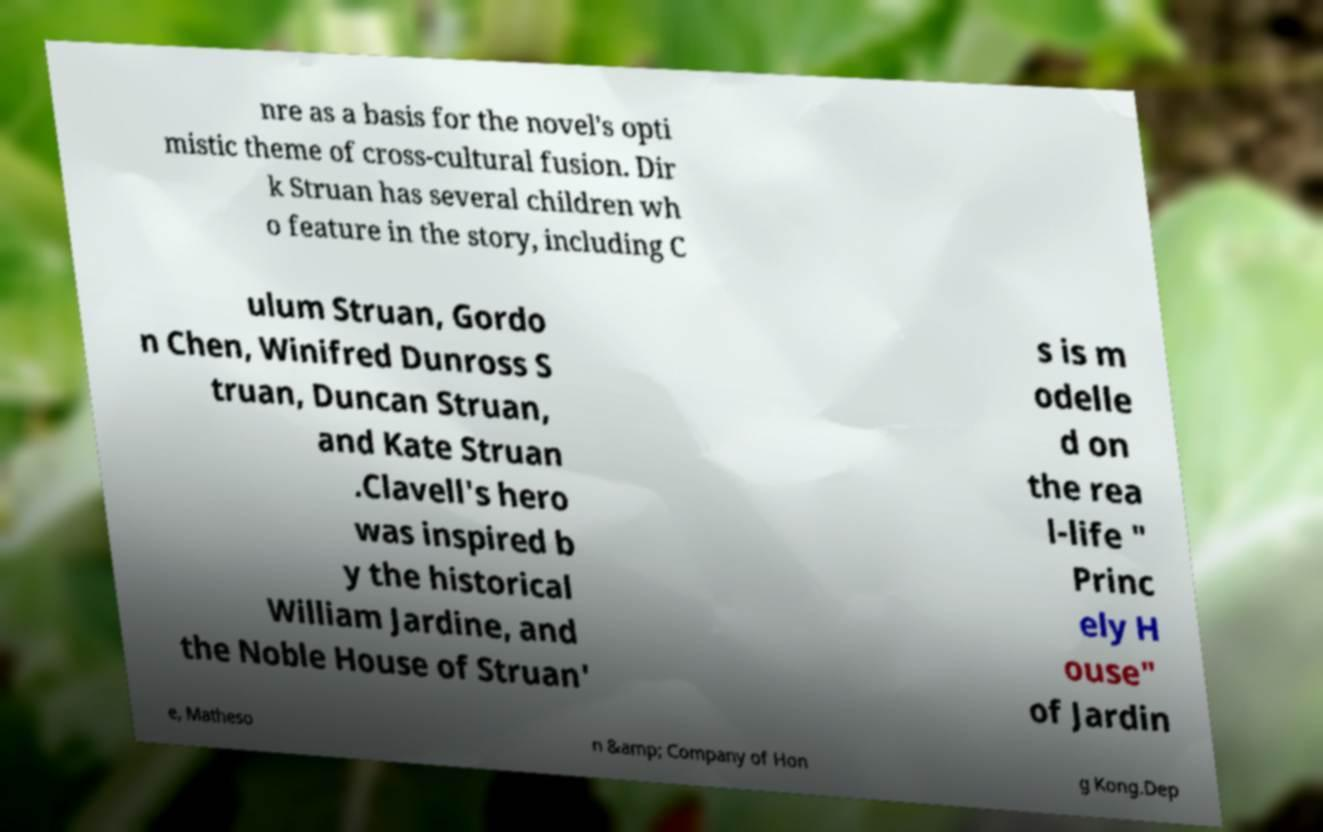What messages or text are displayed in this image? I need them in a readable, typed format. nre as a basis for the novel's opti mistic theme of cross-cultural fusion. Dir k Struan has several children wh o feature in the story, including C ulum Struan, Gordo n Chen, Winifred Dunross S truan, Duncan Struan, and Kate Struan .Clavell's hero was inspired b y the historical William Jardine, and the Noble House of Struan' s is m odelle d on the rea l-life " Princ ely H ouse" of Jardin e, Matheso n &amp; Company of Hon g Kong.Dep 